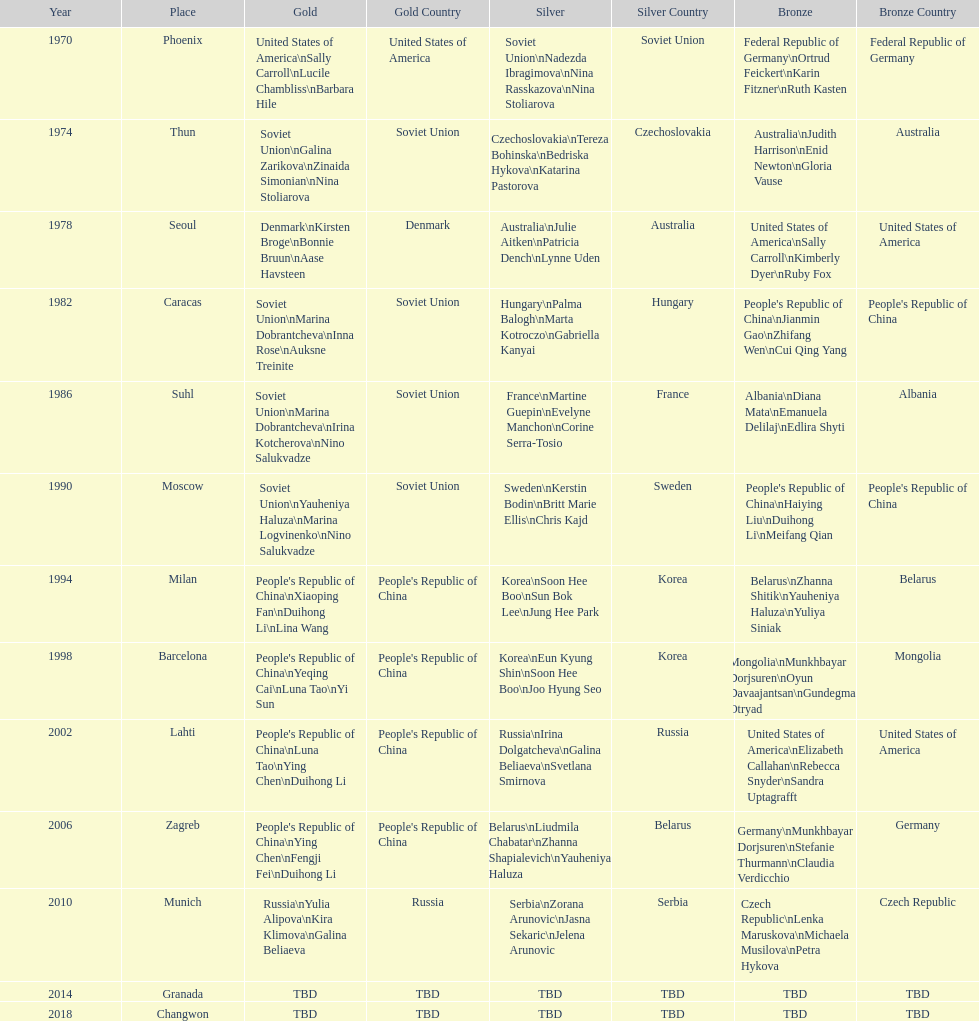Which country is listed the most under the silver column? Korea. 